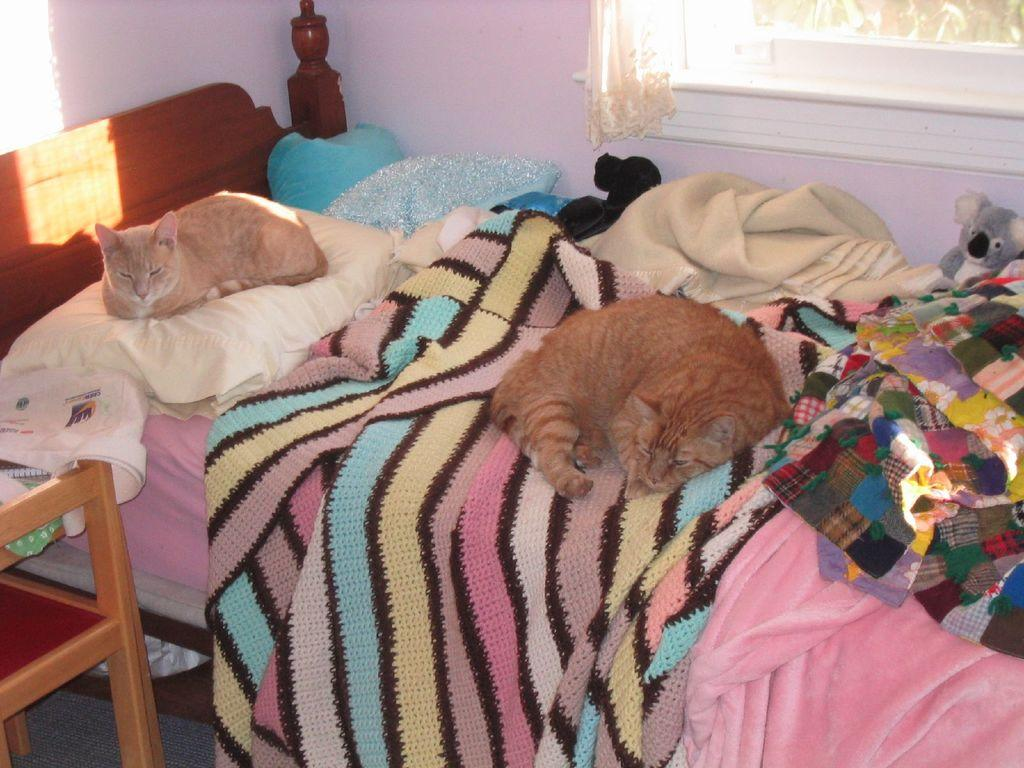How many cats are in the image? There are two cats in the image. Where are the cats located? The cats are on a bed. What else can be seen in the image besides the cats? There is a window and a teddy bear visible in the image. What type of representative is present in the image? There is no representative present in the image; it features two cats, a bed, a window, and a teddy bear. Can you describe the pear in the image? There is no pear present in the image. 